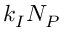<formula> <loc_0><loc_0><loc_500><loc_500>k _ { I } N _ { P }</formula> 